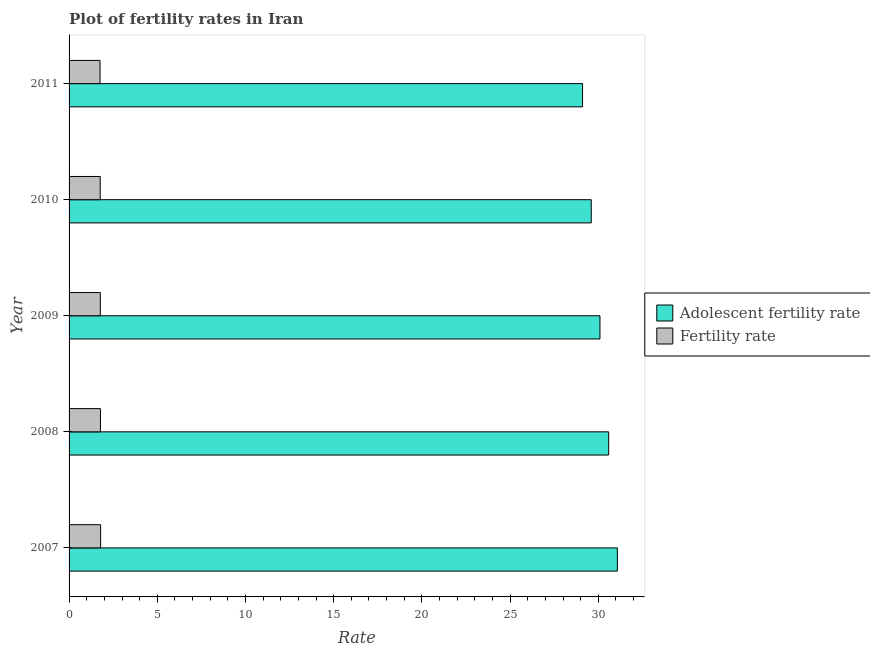Are the number of bars on each tick of the Y-axis equal?
Give a very brief answer. Yes. How many bars are there on the 1st tick from the top?
Make the answer very short. 2. What is the label of the 5th group of bars from the top?
Give a very brief answer. 2007. In how many cases, is the number of bars for a given year not equal to the number of legend labels?
Provide a succinct answer. 0. What is the fertility rate in 2008?
Offer a very short reply. 1.78. Across all years, what is the maximum adolescent fertility rate?
Your answer should be very brief. 31.08. Across all years, what is the minimum fertility rate?
Provide a short and direct response. 1.75. In which year was the fertility rate maximum?
Provide a short and direct response. 2007. In which year was the fertility rate minimum?
Ensure brevity in your answer.  2011. What is the total adolescent fertility rate in the graph?
Offer a terse response. 150.46. What is the difference between the adolescent fertility rate in 2007 and that in 2010?
Your answer should be very brief. 1.48. What is the difference between the fertility rate in 2009 and the adolescent fertility rate in 2007?
Provide a short and direct response. -29.31. What is the average adolescent fertility rate per year?
Your answer should be very brief. 30.09. In the year 2008, what is the difference between the adolescent fertility rate and fertility rate?
Your answer should be compact. 28.81. In how many years, is the fertility rate greater than 30 ?
Your response must be concise. 0. What is the ratio of the adolescent fertility rate in 2009 to that in 2011?
Make the answer very short. 1.03. What is the difference between the highest and the second highest fertility rate?
Offer a terse response. 0.01. What is the difference between the highest and the lowest fertility rate?
Provide a short and direct response. 0.03. Is the sum of the fertility rate in 2008 and 2010 greater than the maximum adolescent fertility rate across all years?
Provide a succinct answer. No. What does the 1st bar from the top in 2011 represents?
Provide a short and direct response. Fertility rate. What does the 2nd bar from the bottom in 2007 represents?
Your answer should be compact. Fertility rate. How many bars are there?
Offer a very short reply. 10. Are all the bars in the graph horizontal?
Give a very brief answer. Yes. How many years are there in the graph?
Provide a short and direct response. 5. What is the difference between two consecutive major ticks on the X-axis?
Your answer should be compact. 5. Does the graph contain grids?
Offer a very short reply. No. Where does the legend appear in the graph?
Ensure brevity in your answer.  Center right. How are the legend labels stacked?
Provide a short and direct response. Vertical. What is the title of the graph?
Your response must be concise. Plot of fertility rates in Iran. Does "Food" appear as one of the legend labels in the graph?
Ensure brevity in your answer.  No. What is the label or title of the X-axis?
Provide a short and direct response. Rate. What is the label or title of the Y-axis?
Make the answer very short. Year. What is the Rate of Adolescent fertility rate in 2007?
Offer a terse response. 31.08. What is the Rate of Fertility rate in 2007?
Ensure brevity in your answer.  1.79. What is the Rate in Adolescent fertility rate in 2008?
Offer a very short reply. 30.59. What is the Rate in Fertility rate in 2008?
Give a very brief answer. 1.78. What is the Rate of Adolescent fertility rate in 2009?
Offer a very short reply. 30.09. What is the Rate of Fertility rate in 2009?
Provide a succinct answer. 1.77. What is the Rate of Adolescent fertility rate in 2010?
Your response must be concise. 29.6. What is the Rate in Fertility rate in 2010?
Ensure brevity in your answer.  1.76. What is the Rate of Adolescent fertility rate in 2011?
Your answer should be compact. 29.11. What is the Rate in Fertility rate in 2011?
Offer a very short reply. 1.75. Across all years, what is the maximum Rate in Adolescent fertility rate?
Your response must be concise. 31.08. Across all years, what is the maximum Rate of Fertility rate?
Keep it short and to the point. 1.79. Across all years, what is the minimum Rate in Adolescent fertility rate?
Your answer should be very brief. 29.11. Across all years, what is the minimum Rate of Fertility rate?
Give a very brief answer. 1.75. What is the total Rate of Adolescent fertility rate in the graph?
Provide a succinct answer. 150.46. What is the total Rate in Fertility rate in the graph?
Offer a terse response. 8.86. What is the difference between the Rate in Adolescent fertility rate in 2007 and that in 2008?
Give a very brief answer. 0.49. What is the difference between the Rate of Fertility rate in 2007 and that in 2008?
Offer a very short reply. 0.01. What is the difference between the Rate in Fertility rate in 2007 and that in 2009?
Offer a terse response. 0.02. What is the difference between the Rate in Adolescent fertility rate in 2007 and that in 2010?
Give a very brief answer. 1.48. What is the difference between the Rate of Fertility rate in 2007 and that in 2010?
Make the answer very short. 0.02. What is the difference between the Rate of Adolescent fertility rate in 2007 and that in 2011?
Provide a succinct answer. 1.97. What is the difference between the Rate in Fertility rate in 2007 and that in 2011?
Provide a short and direct response. 0.03. What is the difference between the Rate of Adolescent fertility rate in 2008 and that in 2009?
Give a very brief answer. 0.49. What is the difference between the Rate of Fertility rate in 2008 and that in 2009?
Ensure brevity in your answer.  0.01. What is the difference between the Rate in Adolescent fertility rate in 2008 and that in 2010?
Keep it short and to the point. 0.99. What is the difference between the Rate of Fertility rate in 2008 and that in 2010?
Provide a short and direct response. 0.01. What is the difference between the Rate of Adolescent fertility rate in 2008 and that in 2011?
Offer a very short reply. 1.48. What is the difference between the Rate in Fertility rate in 2008 and that in 2011?
Provide a short and direct response. 0.02. What is the difference between the Rate in Adolescent fertility rate in 2009 and that in 2010?
Offer a very short reply. 0.49. What is the difference between the Rate of Fertility rate in 2009 and that in 2010?
Offer a terse response. 0.01. What is the difference between the Rate of Adolescent fertility rate in 2009 and that in 2011?
Your answer should be very brief. 0.99. What is the difference between the Rate in Fertility rate in 2009 and that in 2011?
Give a very brief answer. 0.02. What is the difference between the Rate of Adolescent fertility rate in 2010 and that in 2011?
Your answer should be compact. 0.49. What is the difference between the Rate in Fertility rate in 2010 and that in 2011?
Offer a terse response. 0.01. What is the difference between the Rate of Adolescent fertility rate in 2007 and the Rate of Fertility rate in 2008?
Keep it short and to the point. 29.3. What is the difference between the Rate of Adolescent fertility rate in 2007 and the Rate of Fertility rate in 2009?
Give a very brief answer. 29.31. What is the difference between the Rate in Adolescent fertility rate in 2007 and the Rate in Fertility rate in 2010?
Provide a succinct answer. 29.31. What is the difference between the Rate of Adolescent fertility rate in 2007 and the Rate of Fertility rate in 2011?
Your answer should be compact. 29.32. What is the difference between the Rate in Adolescent fertility rate in 2008 and the Rate in Fertility rate in 2009?
Your response must be concise. 28.81. What is the difference between the Rate in Adolescent fertility rate in 2008 and the Rate in Fertility rate in 2010?
Offer a terse response. 28.82. What is the difference between the Rate in Adolescent fertility rate in 2008 and the Rate in Fertility rate in 2011?
Ensure brevity in your answer.  28.83. What is the difference between the Rate of Adolescent fertility rate in 2009 and the Rate of Fertility rate in 2010?
Provide a short and direct response. 28.33. What is the difference between the Rate of Adolescent fertility rate in 2009 and the Rate of Fertility rate in 2011?
Ensure brevity in your answer.  28.34. What is the difference between the Rate in Adolescent fertility rate in 2010 and the Rate in Fertility rate in 2011?
Your response must be concise. 27.84. What is the average Rate of Adolescent fertility rate per year?
Provide a short and direct response. 30.09. What is the average Rate of Fertility rate per year?
Offer a very short reply. 1.77. In the year 2007, what is the difference between the Rate of Adolescent fertility rate and Rate of Fertility rate?
Provide a succinct answer. 29.29. In the year 2008, what is the difference between the Rate in Adolescent fertility rate and Rate in Fertility rate?
Your response must be concise. 28.81. In the year 2009, what is the difference between the Rate in Adolescent fertility rate and Rate in Fertility rate?
Your answer should be compact. 28.32. In the year 2010, what is the difference between the Rate in Adolescent fertility rate and Rate in Fertility rate?
Make the answer very short. 27.83. In the year 2011, what is the difference between the Rate of Adolescent fertility rate and Rate of Fertility rate?
Offer a terse response. 27.35. What is the ratio of the Rate of Adolescent fertility rate in 2007 to that in 2008?
Provide a short and direct response. 1.02. What is the ratio of the Rate in Fertility rate in 2007 to that in 2008?
Your response must be concise. 1.01. What is the ratio of the Rate of Adolescent fertility rate in 2007 to that in 2009?
Offer a very short reply. 1.03. What is the ratio of the Rate of Fertility rate in 2007 to that in 2009?
Keep it short and to the point. 1.01. What is the ratio of the Rate of Adolescent fertility rate in 2007 to that in 2010?
Make the answer very short. 1.05. What is the ratio of the Rate of Adolescent fertility rate in 2007 to that in 2011?
Your response must be concise. 1.07. What is the ratio of the Rate in Fertility rate in 2007 to that in 2011?
Provide a short and direct response. 1.02. What is the ratio of the Rate of Adolescent fertility rate in 2008 to that in 2009?
Keep it short and to the point. 1.02. What is the ratio of the Rate of Fertility rate in 2008 to that in 2009?
Give a very brief answer. 1. What is the ratio of the Rate in Adolescent fertility rate in 2008 to that in 2010?
Keep it short and to the point. 1.03. What is the ratio of the Rate in Fertility rate in 2008 to that in 2010?
Your answer should be compact. 1.01. What is the ratio of the Rate in Adolescent fertility rate in 2008 to that in 2011?
Provide a short and direct response. 1.05. What is the ratio of the Rate in Fertility rate in 2008 to that in 2011?
Ensure brevity in your answer.  1.01. What is the ratio of the Rate in Adolescent fertility rate in 2009 to that in 2010?
Your answer should be compact. 1.02. What is the ratio of the Rate of Adolescent fertility rate in 2009 to that in 2011?
Offer a terse response. 1.03. What is the ratio of the Rate of Fertility rate in 2009 to that in 2011?
Give a very brief answer. 1.01. What is the ratio of the Rate of Adolescent fertility rate in 2010 to that in 2011?
Keep it short and to the point. 1.02. What is the difference between the highest and the second highest Rate of Adolescent fertility rate?
Your answer should be very brief. 0.49. What is the difference between the highest and the second highest Rate in Fertility rate?
Your response must be concise. 0.01. What is the difference between the highest and the lowest Rate of Adolescent fertility rate?
Offer a terse response. 1.97. What is the difference between the highest and the lowest Rate in Fertility rate?
Keep it short and to the point. 0.03. 